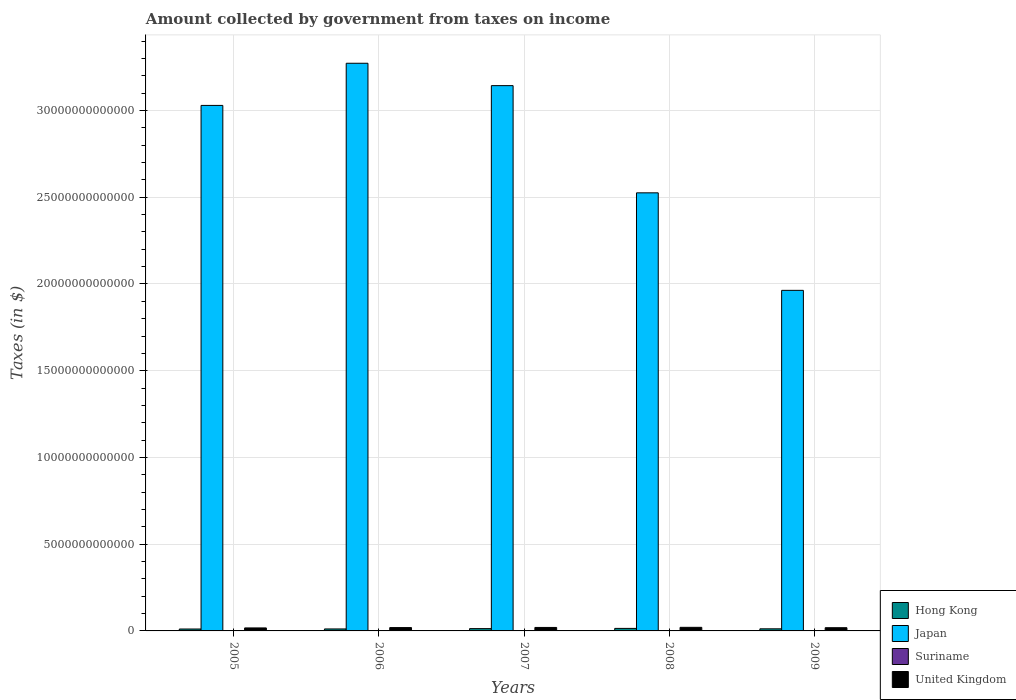How many different coloured bars are there?
Provide a short and direct response. 4. How many groups of bars are there?
Ensure brevity in your answer.  5. Are the number of bars per tick equal to the number of legend labels?
Your answer should be compact. Yes. What is the label of the 2nd group of bars from the left?
Give a very brief answer. 2006. What is the amount collected by government from taxes on income in Suriname in 2009?
Your answer should be very brief. 7.49e+08. Across all years, what is the maximum amount collected by government from taxes on income in United Kingdom?
Provide a short and direct response. 2.07e+11. Across all years, what is the minimum amount collected by government from taxes on income in Hong Kong?
Offer a very short reply. 1.10e+11. In which year was the amount collected by government from taxes on income in Suriname maximum?
Provide a short and direct response. 2009. What is the total amount collected by government from taxes on income in Suriname in the graph?
Keep it short and to the point. 2.81e+09. What is the difference between the amount collected by government from taxes on income in United Kingdom in 2005 and that in 2007?
Keep it short and to the point. -2.75e+1. What is the difference between the amount collected by government from taxes on income in Hong Kong in 2008 and the amount collected by government from taxes on income in Japan in 2009?
Offer a terse response. -1.95e+13. What is the average amount collected by government from taxes on income in Suriname per year?
Make the answer very short. 5.61e+08. In the year 2007, what is the difference between the amount collected by government from taxes on income in Hong Kong and amount collected by government from taxes on income in United Kingdom?
Offer a terse response. -6.76e+1. In how many years, is the amount collected by government from taxes on income in Hong Kong greater than 25000000000000 $?
Give a very brief answer. 0. What is the ratio of the amount collected by government from taxes on income in Hong Kong in 2006 to that in 2009?
Your answer should be compact. 0.94. Is the difference between the amount collected by government from taxes on income in Hong Kong in 2005 and 2009 greater than the difference between the amount collected by government from taxes on income in United Kingdom in 2005 and 2009?
Give a very brief answer. Yes. What is the difference between the highest and the second highest amount collected by government from taxes on income in Suriname?
Make the answer very short. 1.16e+08. What is the difference between the highest and the lowest amount collected by government from taxes on income in Suriname?
Provide a succinct answer. 3.59e+08. Is the sum of the amount collected by government from taxes on income in United Kingdom in 2006 and 2007 greater than the maximum amount collected by government from taxes on income in Japan across all years?
Keep it short and to the point. No. Is it the case that in every year, the sum of the amount collected by government from taxes on income in Suriname and amount collected by government from taxes on income in Japan is greater than the sum of amount collected by government from taxes on income in Hong Kong and amount collected by government from taxes on income in United Kingdom?
Ensure brevity in your answer.  Yes. What does the 3rd bar from the left in 2007 represents?
Keep it short and to the point. Suriname. Is it the case that in every year, the sum of the amount collected by government from taxes on income in Suriname and amount collected by government from taxes on income in United Kingdom is greater than the amount collected by government from taxes on income in Japan?
Provide a succinct answer. No. How many bars are there?
Offer a very short reply. 20. Are all the bars in the graph horizontal?
Provide a succinct answer. No. How many years are there in the graph?
Provide a short and direct response. 5. What is the difference between two consecutive major ticks on the Y-axis?
Provide a succinct answer. 5.00e+12. Where does the legend appear in the graph?
Offer a terse response. Bottom right. What is the title of the graph?
Provide a succinct answer. Amount collected by government from taxes on income. Does "East Asia (all income levels)" appear as one of the legend labels in the graph?
Provide a short and direct response. No. What is the label or title of the X-axis?
Give a very brief answer. Years. What is the label or title of the Y-axis?
Ensure brevity in your answer.  Taxes (in $). What is the Taxes (in $) in Hong Kong in 2005?
Offer a terse response. 1.10e+11. What is the Taxes (in $) of Japan in 2005?
Your answer should be compact. 3.03e+13. What is the Taxes (in $) of Suriname in 2005?
Make the answer very short. 3.90e+08. What is the Taxes (in $) of United Kingdom in 2005?
Your response must be concise. 1.72e+11. What is the Taxes (in $) in Hong Kong in 2006?
Offer a very short reply. 1.14e+11. What is the Taxes (in $) in Japan in 2006?
Ensure brevity in your answer.  3.27e+13. What is the Taxes (in $) in Suriname in 2006?
Your response must be concise. 4.40e+08. What is the Taxes (in $) of United Kingdom in 2006?
Your response must be concise. 1.93e+11. What is the Taxes (in $) of Hong Kong in 2007?
Provide a short and direct response. 1.32e+11. What is the Taxes (in $) of Japan in 2007?
Ensure brevity in your answer.  3.14e+13. What is the Taxes (in $) of Suriname in 2007?
Keep it short and to the point. 5.95e+08. What is the Taxes (in $) in United Kingdom in 2007?
Your answer should be compact. 2.00e+11. What is the Taxes (in $) of Hong Kong in 2008?
Ensure brevity in your answer.  1.45e+11. What is the Taxes (in $) in Japan in 2008?
Offer a terse response. 2.53e+13. What is the Taxes (in $) of Suriname in 2008?
Keep it short and to the point. 6.34e+08. What is the Taxes (in $) in United Kingdom in 2008?
Keep it short and to the point. 2.07e+11. What is the Taxes (in $) in Hong Kong in 2009?
Provide a succinct answer. 1.22e+11. What is the Taxes (in $) of Japan in 2009?
Ensure brevity in your answer.  1.96e+13. What is the Taxes (in $) in Suriname in 2009?
Offer a terse response. 7.49e+08. What is the Taxes (in $) in United Kingdom in 2009?
Offer a terse response. 1.85e+11. Across all years, what is the maximum Taxes (in $) of Hong Kong?
Give a very brief answer. 1.45e+11. Across all years, what is the maximum Taxes (in $) of Japan?
Your response must be concise. 3.27e+13. Across all years, what is the maximum Taxes (in $) of Suriname?
Make the answer very short. 7.49e+08. Across all years, what is the maximum Taxes (in $) in United Kingdom?
Your answer should be very brief. 2.07e+11. Across all years, what is the minimum Taxes (in $) in Hong Kong?
Your response must be concise. 1.10e+11. Across all years, what is the minimum Taxes (in $) in Japan?
Your response must be concise. 1.96e+13. Across all years, what is the minimum Taxes (in $) in Suriname?
Your answer should be compact. 3.90e+08. Across all years, what is the minimum Taxes (in $) of United Kingdom?
Offer a terse response. 1.72e+11. What is the total Taxes (in $) in Hong Kong in the graph?
Give a very brief answer. 6.24e+11. What is the total Taxes (in $) of Japan in the graph?
Keep it short and to the point. 1.39e+14. What is the total Taxes (in $) in Suriname in the graph?
Your answer should be very brief. 2.81e+09. What is the total Taxes (in $) of United Kingdom in the graph?
Your answer should be very brief. 9.57e+11. What is the difference between the Taxes (in $) in Hong Kong in 2005 and that in 2006?
Offer a very short reply. -3.58e+09. What is the difference between the Taxes (in $) in Japan in 2005 and that in 2006?
Offer a very short reply. -2.43e+12. What is the difference between the Taxes (in $) in Suriname in 2005 and that in 2006?
Your response must be concise. -4.96e+07. What is the difference between the Taxes (in $) in United Kingdom in 2005 and that in 2006?
Make the answer very short. -2.01e+1. What is the difference between the Taxes (in $) in Hong Kong in 2005 and that in 2007?
Your answer should be very brief. -2.20e+1. What is the difference between the Taxes (in $) in Japan in 2005 and that in 2007?
Keep it short and to the point. -1.14e+12. What is the difference between the Taxes (in $) of Suriname in 2005 and that in 2007?
Offer a terse response. -2.05e+08. What is the difference between the Taxes (in $) of United Kingdom in 2005 and that in 2007?
Your answer should be very brief. -2.75e+1. What is the difference between the Taxes (in $) in Hong Kong in 2005 and that in 2008?
Your answer should be very brief. -3.48e+1. What is the difference between the Taxes (in $) in Japan in 2005 and that in 2008?
Your answer should be very brief. 5.04e+12. What is the difference between the Taxes (in $) in Suriname in 2005 and that in 2008?
Ensure brevity in your answer.  -2.44e+08. What is the difference between the Taxes (in $) of United Kingdom in 2005 and that in 2008?
Keep it short and to the point. -3.44e+1. What is the difference between the Taxes (in $) of Hong Kong in 2005 and that in 2009?
Your answer should be very brief. -1.10e+1. What is the difference between the Taxes (in $) in Japan in 2005 and that in 2009?
Ensure brevity in your answer.  1.07e+13. What is the difference between the Taxes (in $) of Suriname in 2005 and that in 2009?
Your answer should be compact. -3.59e+08. What is the difference between the Taxes (in $) in United Kingdom in 2005 and that in 2009?
Your answer should be compact. -1.23e+1. What is the difference between the Taxes (in $) in Hong Kong in 2006 and that in 2007?
Offer a very short reply. -1.84e+1. What is the difference between the Taxes (in $) of Japan in 2006 and that in 2007?
Your answer should be compact. 1.29e+12. What is the difference between the Taxes (in $) of Suriname in 2006 and that in 2007?
Your answer should be very brief. -1.55e+08. What is the difference between the Taxes (in $) in United Kingdom in 2006 and that in 2007?
Offer a very short reply. -7.44e+09. What is the difference between the Taxes (in $) of Hong Kong in 2006 and that in 2008?
Provide a short and direct response. -3.12e+1. What is the difference between the Taxes (in $) in Japan in 2006 and that in 2008?
Provide a succinct answer. 7.47e+12. What is the difference between the Taxes (in $) of Suriname in 2006 and that in 2008?
Make the answer very short. -1.94e+08. What is the difference between the Taxes (in $) in United Kingdom in 2006 and that in 2008?
Your answer should be very brief. -1.43e+1. What is the difference between the Taxes (in $) of Hong Kong in 2006 and that in 2009?
Make the answer very short. -7.44e+09. What is the difference between the Taxes (in $) of Japan in 2006 and that in 2009?
Your response must be concise. 1.31e+13. What is the difference between the Taxes (in $) of Suriname in 2006 and that in 2009?
Offer a very short reply. -3.10e+08. What is the difference between the Taxes (in $) of United Kingdom in 2006 and that in 2009?
Provide a succinct answer. 7.80e+09. What is the difference between the Taxes (in $) of Hong Kong in 2007 and that in 2008?
Provide a short and direct response. -1.28e+1. What is the difference between the Taxes (in $) in Japan in 2007 and that in 2008?
Ensure brevity in your answer.  6.18e+12. What is the difference between the Taxes (in $) in Suriname in 2007 and that in 2008?
Keep it short and to the point. -3.89e+07. What is the difference between the Taxes (in $) of United Kingdom in 2007 and that in 2008?
Offer a very short reply. -6.88e+09. What is the difference between the Taxes (in $) in Hong Kong in 2007 and that in 2009?
Make the answer very short. 1.10e+1. What is the difference between the Taxes (in $) in Japan in 2007 and that in 2009?
Offer a terse response. 1.18e+13. What is the difference between the Taxes (in $) in Suriname in 2007 and that in 2009?
Ensure brevity in your answer.  -1.55e+08. What is the difference between the Taxes (in $) in United Kingdom in 2007 and that in 2009?
Offer a terse response. 1.52e+1. What is the difference between the Taxes (in $) in Hong Kong in 2008 and that in 2009?
Your answer should be very brief. 2.38e+1. What is the difference between the Taxes (in $) in Japan in 2008 and that in 2009?
Your answer should be compact. 5.62e+12. What is the difference between the Taxes (in $) of Suriname in 2008 and that in 2009?
Make the answer very short. -1.16e+08. What is the difference between the Taxes (in $) of United Kingdom in 2008 and that in 2009?
Offer a very short reply. 2.21e+1. What is the difference between the Taxes (in $) in Hong Kong in 2005 and the Taxes (in $) in Japan in 2006?
Provide a short and direct response. -3.26e+13. What is the difference between the Taxes (in $) in Hong Kong in 2005 and the Taxes (in $) in Suriname in 2006?
Keep it short and to the point. 1.10e+11. What is the difference between the Taxes (in $) of Hong Kong in 2005 and the Taxes (in $) of United Kingdom in 2006?
Offer a terse response. -8.21e+1. What is the difference between the Taxes (in $) in Japan in 2005 and the Taxes (in $) in Suriname in 2006?
Offer a terse response. 3.03e+13. What is the difference between the Taxes (in $) of Japan in 2005 and the Taxes (in $) of United Kingdom in 2006?
Your answer should be compact. 3.01e+13. What is the difference between the Taxes (in $) of Suriname in 2005 and the Taxes (in $) of United Kingdom in 2006?
Offer a terse response. -1.92e+11. What is the difference between the Taxes (in $) in Hong Kong in 2005 and the Taxes (in $) in Japan in 2007?
Keep it short and to the point. -3.13e+13. What is the difference between the Taxes (in $) of Hong Kong in 2005 and the Taxes (in $) of Suriname in 2007?
Make the answer very short. 1.10e+11. What is the difference between the Taxes (in $) in Hong Kong in 2005 and the Taxes (in $) in United Kingdom in 2007?
Your answer should be compact. -8.96e+1. What is the difference between the Taxes (in $) in Japan in 2005 and the Taxes (in $) in Suriname in 2007?
Your answer should be very brief. 3.03e+13. What is the difference between the Taxes (in $) in Japan in 2005 and the Taxes (in $) in United Kingdom in 2007?
Ensure brevity in your answer.  3.01e+13. What is the difference between the Taxes (in $) of Suriname in 2005 and the Taxes (in $) of United Kingdom in 2007?
Your answer should be compact. -2.00e+11. What is the difference between the Taxes (in $) of Hong Kong in 2005 and the Taxes (in $) of Japan in 2008?
Offer a very short reply. -2.51e+13. What is the difference between the Taxes (in $) in Hong Kong in 2005 and the Taxes (in $) in Suriname in 2008?
Your answer should be very brief. 1.10e+11. What is the difference between the Taxes (in $) in Hong Kong in 2005 and the Taxes (in $) in United Kingdom in 2008?
Your answer should be very brief. -9.64e+1. What is the difference between the Taxes (in $) of Japan in 2005 and the Taxes (in $) of Suriname in 2008?
Ensure brevity in your answer.  3.03e+13. What is the difference between the Taxes (in $) in Japan in 2005 and the Taxes (in $) in United Kingdom in 2008?
Offer a very short reply. 3.01e+13. What is the difference between the Taxes (in $) of Suriname in 2005 and the Taxes (in $) of United Kingdom in 2008?
Provide a succinct answer. -2.07e+11. What is the difference between the Taxes (in $) in Hong Kong in 2005 and the Taxes (in $) in Japan in 2009?
Give a very brief answer. -1.95e+13. What is the difference between the Taxes (in $) in Hong Kong in 2005 and the Taxes (in $) in Suriname in 2009?
Your answer should be very brief. 1.10e+11. What is the difference between the Taxes (in $) in Hong Kong in 2005 and the Taxes (in $) in United Kingdom in 2009?
Offer a terse response. -7.43e+1. What is the difference between the Taxes (in $) in Japan in 2005 and the Taxes (in $) in Suriname in 2009?
Make the answer very short. 3.03e+13. What is the difference between the Taxes (in $) of Japan in 2005 and the Taxes (in $) of United Kingdom in 2009?
Offer a terse response. 3.01e+13. What is the difference between the Taxes (in $) in Suriname in 2005 and the Taxes (in $) in United Kingdom in 2009?
Your answer should be compact. -1.84e+11. What is the difference between the Taxes (in $) of Hong Kong in 2006 and the Taxes (in $) of Japan in 2007?
Your answer should be very brief. -3.13e+13. What is the difference between the Taxes (in $) of Hong Kong in 2006 and the Taxes (in $) of Suriname in 2007?
Offer a very short reply. 1.13e+11. What is the difference between the Taxes (in $) of Hong Kong in 2006 and the Taxes (in $) of United Kingdom in 2007?
Keep it short and to the point. -8.60e+1. What is the difference between the Taxes (in $) of Japan in 2006 and the Taxes (in $) of Suriname in 2007?
Offer a terse response. 3.27e+13. What is the difference between the Taxes (in $) in Japan in 2006 and the Taxes (in $) in United Kingdom in 2007?
Keep it short and to the point. 3.25e+13. What is the difference between the Taxes (in $) in Suriname in 2006 and the Taxes (in $) in United Kingdom in 2007?
Your answer should be compact. -2.00e+11. What is the difference between the Taxes (in $) of Hong Kong in 2006 and the Taxes (in $) of Japan in 2008?
Your answer should be compact. -2.51e+13. What is the difference between the Taxes (in $) in Hong Kong in 2006 and the Taxes (in $) in Suriname in 2008?
Your answer should be very brief. 1.13e+11. What is the difference between the Taxes (in $) in Hong Kong in 2006 and the Taxes (in $) in United Kingdom in 2008?
Your response must be concise. -9.28e+1. What is the difference between the Taxes (in $) in Japan in 2006 and the Taxes (in $) in Suriname in 2008?
Offer a terse response. 3.27e+13. What is the difference between the Taxes (in $) in Japan in 2006 and the Taxes (in $) in United Kingdom in 2008?
Your response must be concise. 3.25e+13. What is the difference between the Taxes (in $) in Suriname in 2006 and the Taxes (in $) in United Kingdom in 2008?
Your response must be concise. -2.06e+11. What is the difference between the Taxes (in $) of Hong Kong in 2006 and the Taxes (in $) of Japan in 2009?
Make the answer very short. -1.95e+13. What is the difference between the Taxes (in $) in Hong Kong in 2006 and the Taxes (in $) in Suriname in 2009?
Provide a succinct answer. 1.13e+11. What is the difference between the Taxes (in $) in Hong Kong in 2006 and the Taxes (in $) in United Kingdom in 2009?
Your response must be concise. -7.07e+1. What is the difference between the Taxes (in $) in Japan in 2006 and the Taxes (in $) in Suriname in 2009?
Your answer should be compact. 3.27e+13. What is the difference between the Taxes (in $) in Japan in 2006 and the Taxes (in $) in United Kingdom in 2009?
Provide a short and direct response. 3.25e+13. What is the difference between the Taxes (in $) of Suriname in 2006 and the Taxes (in $) of United Kingdom in 2009?
Your answer should be very brief. -1.84e+11. What is the difference between the Taxes (in $) in Hong Kong in 2007 and the Taxes (in $) in Japan in 2008?
Your answer should be very brief. -2.51e+13. What is the difference between the Taxes (in $) in Hong Kong in 2007 and the Taxes (in $) in Suriname in 2008?
Keep it short and to the point. 1.32e+11. What is the difference between the Taxes (in $) of Hong Kong in 2007 and the Taxes (in $) of United Kingdom in 2008?
Your answer should be compact. -7.44e+1. What is the difference between the Taxes (in $) of Japan in 2007 and the Taxes (in $) of Suriname in 2008?
Offer a very short reply. 3.14e+13. What is the difference between the Taxes (in $) in Japan in 2007 and the Taxes (in $) in United Kingdom in 2008?
Keep it short and to the point. 3.12e+13. What is the difference between the Taxes (in $) of Suriname in 2007 and the Taxes (in $) of United Kingdom in 2008?
Your answer should be very brief. -2.06e+11. What is the difference between the Taxes (in $) of Hong Kong in 2007 and the Taxes (in $) of Japan in 2009?
Offer a terse response. -1.95e+13. What is the difference between the Taxes (in $) of Hong Kong in 2007 and the Taxes (in $) of Suriname in 2009?
Offer a terse response. 1.32e+11. What is the difference between the Taxes (in $) of Hong Kong in 2007 and the Taxes (in $) of United Kingdom in 2009?
Offer a very short reply. -5.23e+1. What is the difference between the Taxes (in $) of Japan in 2007 and the Taxes (in $) of Suriname in 2009?
Offer a terse response. 3.14e+13. What is the difference between the Taxes (in $) of Japan in 2007 and the Taxes (in $) of United Kingdom in 2009?
Your answer should be compact. 3.12e+13. What is the difference between the Taxes (in $) in Suriname in 2007 and the Taxes (in $) in United Kingdom in 2009?
Your answer should be compact. -1.84e+11. What is the difference between the Taxes (in $) in Hong Kong in 2008 and the Taxes (in $) in Japan in 2009?
Make the answer very short. -1.95e+13. What is the difference between the Taxes (in $) in Hong Kong in 2008 and the Taxes (in $) in Suriname in 2009?
Give a very brief answer. 1.45e+11. What is the difference between the Taxes (in $) in Hong Kong in 2008 and the Taxes (in $) in United Kingdom in 2009?
Give a very brief answer. -3.95e+1. What is the difference between the Taxes (in $) of Japan in 2008 and the Taxes (in $) of Suriname in 2009?
Provide a succinct answer. 2.53e+13. What is the difference between the Taxes (in $) in Japan in 2008 and the Taxes (in $) in United Kingdom in 2009?
Offer a terse response. 2.51e+13. What is the difference between the Taxes (in $) of Suriname in 2008 and the Taxes (in $) of United Kingdom in 2009?
Offer a very short reply. -1.84e+11. What is the average Taxes (in $) in Hong Kong per year?
Provide a succinct answer. 1.25e+11. What is the average Taxes (in $) in Japan per year?
Ensure brevity in your answer.  2.79e+13. What is the average Taxes (in $) in Suriname per year?
Ensure brevity in your answer.  5.61e+08. What is the average Taxes (in $) in United Kingdom per year?
Ensure brevity in your answer.  1.91e+11. In the year 2005, what is the difference between the Taxes (in $) in Hong Kong and Taxes (in $) in Japan?
Your response must be concise. -3.02e+13. In the year 2005, what is the difference between the Taxes (in $) of Hong Kong and Taxes (in $) of Suriname?
Ensure brevity in your answer.  1.10e+11. In the year 2005, what is the difference between the Taxes (in $) of Hong Kong and Taxes (in $) of United Kingdom?
Your answer should be compact. -6.20e+1. In the year 2005, what is the difference between the Taxes (in $) in Japan and Taxes (in $) in Suriname?
Offer a terse response. 3.03e+13. In the year 2005, what is the difference between the Taxes (in $) of Japan and Taxes (in $) of United Kingdom?
Your response must be concise. 3.01e+13. In the year 2005, what is the difference between the Taxes (in $) in Suriname and Taxes (in $) in United Kingdom?
Make the answer very short. -1.72e+11. In the year 2006, what is the difference between the Taxes (in $) of Hong Kong and Taxes (in $) of Japan?
Offer a very short reply. -3.26e+13. In the year 2006, what is the difference between the Taxes (in $) of Hong Kong and Taxes (in $) of Suriname?
Provide a succinct answer. 1.14e+11. In the year 2006, what is the difference between the Taxes (in $) in Hong Kong and Taxes (in $) in United Kingdom?
Keep it short and to the point. -7.85e+1. In the year 2006, what is the difference between the Taxes (in $) of Japan and Taxes (in $) of Suriname?
Offer a very short reply. 3.27e+13. In the year 2006, what is the difference between the Taxes (in $) of Japan and Taxes (in $) of United Kingdom?
Give a very brief answer. 3.25e+13. In the year 2006, what is the difference between the Taxes (in $) of Suriname and Taxes (in $) of United Kingdom?
Keep it short and to the point. -1.92e+11. In the year 2007, what is the difference between the Taxes (in $) in Hong Kong and Taxes (in $) in Japan?
Your answer should be very brief. -3.13e+13. In the year 2007, what is the difference between the Taxes (in $) of Hong Kong and Taxes (in $) of Suriname?
Provide a short and direct response. 1.32e+11. In the year 2007, what is the difference between the Taxes (in $) in Hong Kong and Taxes (in $) in United Kingdom?
Your response must be concise. -6.76e+1. In the year 2007, what is the difference between the Taxes (in $) of Japan and Taxes (in $) of Suriname?
Provide a short and direct response. 3.14e+13. In the year 2007, what is the difference between the Taxes (in $) in Japan and Taxes (in $) in United Kingdom?
Your answer should be compact. 3.12e+13. In the year 2007, what is the difference between the Taxes (in $) of Suriname and Taxes (in $) of United Kingdom?
Ensure brevity in your answer.  -1.99e+11. In the year 2008, what is the difference between the Taxes (in $) of Hong Kong and Taxes (in $) of Japan?
Keep it short and to the point. -2.51e+13. In the year 2008, what is the difference between the Taxes (in $) of Hong Kong and Taxes (in $) of Suriname?
Your response must be concise. 1.45e+11. In the year 2008, what is the difference between the Taxes (in $) in Hong Kong and Taxes (in $) in United Kingdom?
Make the answer very short. -6.16e+1. In the year 2008, what is the difference between the Taxes (in $) in Japan and Taxes (in $) in Suriname?
Make the answer very short. 2.53e+13. In the year 2008, what is the difference between the Taxes (in $) of Japan and Taxes (in $) of United Kingdom?
Provide a succinct answer. 2.50e+13. In the year 2008, what is the difference between the Taxes (in $) in Suriname and Taxes (in $) in United Kingdom?
Keep it short and to the point. -2.06e+11. In the year 2009, what is the difference between the Taxes (in $) in Hong Kong and Taxes (in $) in Japan?
Your answer should be compact. -1.95e+13. In the year 2009, what is the difference between the Taxes (in $) of Hong Kong and Taxes (in $) of Suriname?
Provide a succinct answer. 1.21e+11. In the year 2009, what is the difference between the Taxes (in $) of Hong Kong and Taxes (in $) of United Kingdom?
Your answer should be very brief. -6.33e+1. In the year 2009, what is the difference between the Taxes (in $) of Japan and Taxes (in $) of Suriname?
Give a very brief answer. 1.96e+13. In the year 2009, what is the difference between the Taxes (in $) in Japan and Taxes (in $) in United Kingdom?
Your answer should be very brief. 1.94e+13. In the year 2009, what is the difference between the Taxes (in $) of Suriname and Taxes (in $) of United Kingdom?
Ensure brevity in your answer.  -1.84e+11. What is the ratio of the Taxes (in $) in Hong Kong in 2005 to that in 2006?
Your answer should be very brief. 0.97. What is the ratio of the Taxes (in $) in Japan in 2005 to that in 2006?
Your response must be concise. 0.93. What is the ratio of the Taxes (in $) of Suriname in 2005 to that in 2006?
Give a very brief answer. 0.89. What is the ratio of the Taxes (in $) in United Kingdom in 2005 to that in 2006?
Your response must be concise. 0.9. What is the ratio of the Taxes (in $) of Hong Kong in 2005 to that in 2007?
Make the answer very short. 0.83. What is the ratio of the Taxes (in $) in Japan in 2005 to that in 2007?
Provide a succinct answer. 0.96. What is the ratio of the Taxes (in $) of Suriname in 2005 to that in 2007?
Your answer should be very brief. 0.66. What is the ratio of the Taxes (in $) in United Kingdom in 2005 to that in 2007?
Your response must be concise. 0.86. What is the ratio of the Taxes (in $) in Hong Kong in 2005 to that in 2008?
Offer a very short reply. 0.76. What is the ratio of the Taxes (in $) of Japan in 2005 to that in 2008?
Provide a short and direct response. 1.2. What is the ratio of the Taxes (in $) in Suriname in 2005 to that in 2008?
Give a very brief answer. 0.62. What is the ratio of the Taxes (in $) in United Kingdom in 2005 to that in 2008?
Offer a terse response. 0.83. What is the ratio of the Taxes (in $) of Hong Kong in 2005 to that in 2009?
Keep it short and to the point. 0.91. What is the ratio of the Taxes (in $) in Japan in 2005 to that in 2009?
Ensure brevity in your answer.  1.54. What is the ratio of the Taxes (in $) in Suriname in 2005 to that in 2009?
Ensure brevity in your answer.  0.52. What is the ratio of the Taxes (in $) of United Kingdom in 2005 to that in 2009?
Your answer should be compact. 0.93. What is the ratio of the Taxes (in $) of Hong Kong in 2006 to that in 2007?
Provide a short and direct response. 0.86. What is the ratio of the Taxes (in $) of Japan in 2006 to that in 2007?
Ensure brevity in your answer.  1.04. What is the ratio of the Taxes (in $) in Suriname in 2006 to that in 2007?
Ensure brevity in your answer.  0.74. What is the ratio of the Taxes (in $) in United Kingdom in 2006 to that in 2007?
Your response must be concise. 0.96. What is the ratio of the Taxes (in $) of Hong Kong in 2006 to that in 2008?
Your response must be concise. 0.78. What is the ratio of the Taxes (in $) in Japan in 2006 to that in 2008?
Offer a terse response. 1.3. What is the ratio of the Taxes (in $) in Suriname in 2006 to that in 2008?
Ensure brevity in your answer.  0.69. What is the ratio of the Taxes (in $) of United Kingdom in 2006 to that in 2008?
Make the answer very short. 0.93. What is the ratio of the Taxes (in $) of Hong Kong in 2006 to that in 2009?
Your answer should be very brief. 0.94. What is the ratio of the Taxes (in $) in Japan in 2006 to that in 2009?
Provide a succinct answer. 1.67. What is the ratio of the Taxes (in $) in Suriname in 2006 to that in 2009?
Keep it short and to the point. 0.59. What is the ratio of the Taxes (in $) of United Kingdom in 2006 to that in 2009?
Keep it short and to the point. 1.04. What is the ratio of the Taxes (in $) in Hong Kong in 2007 to that in 2008?
Offer a very short reply. 0.91. What is the ratio of the Taxes (in $) of Japan in 2007 to that in 2008?
Offer a very short reply. 1.24. What is the ratio of the Taxes (in $) in Suriname in 2007 to that in 2008?
Ensure brevity in your answer.  0.94. What is the ratio of the Taxes (in $) in United Kingdom in 2007 to that in 2008?
Your answer should be compact. 0.97. What is the ratio of the Taxes (in $) in Hong Kong in 2007 to that in 2009?
Keep it short and to the point. 1.09. What is the ratio of the Taxes (in $) in Japan in 2007 to that in 2009?
Ensure brevity in your answer.  1.6. What is the ratio of the Taxes (in $) in Suriname in 2007 to that in 2009?
Make the answer very short. 0.79. What is the ratio of the Taxes (in $) in United Kingdom in 2007 to that in 2009?
Your answer should be very brief. 1.08. What is the ratio of the Taxes (in $) in Hong Kong in 2008 to that in 2009?
Offer a terse response. 1.2. What is the ratio of the Taxes (in $) in Japan in 2008 to that in 2009?
Provide a succinct answer. 1.29. What is the ratio of the Taxes (in $) in Suriname in 2008 to that in 2009?
Your answer should be very brief. 0.85. What is the ratio of the Taxes (in $) of United Kingdom in 2008 to that in 2009?
Offer a very short reply. 1.12. What is the difference between the highest and the second highest Taxes (in $) of Hong Kong?
Your answer should be very brief. 1.28e+1. What is the difference between the highest and the second highest Taxes (in $) of Japan?
Offer a terse response. 1.29e+12. What is the difference between the highest and the second highest Taxes (in $) of Suriname?
Offer a terse response. 1.16e+08. What is the difference between the highest and the second highest Taxes (in $) of United Kingdom?
Your answer should be very brief. 6.88e+09. What is the difference between the highest and the lowest Taxes (in $) of Hong Kong?
Give a very brief answer. 3.48e+1. What is the difference between the highest and the lowest Taxes (in $) of Japan?
Keep it short and to the point. 1.31e+13. What is the difference between the highest and the lowest Taxes (in $) of Suriname?
Keep it short and to the point. 3.59e+08. What is the difference between the highest and the lowest Taxes (in $) of United Kingdom?
Provide a succinct answer. 3.44e+1. 